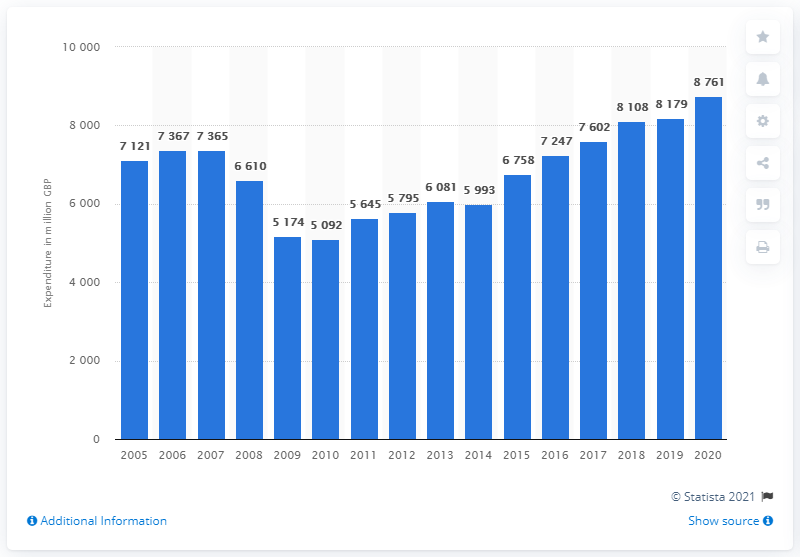Outline some significant characteristics in this image. In 2020, the value of glassware, tableware, and household utensils purchased by households in the UK was 8,761. 